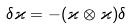<formula> <loc_0><loc_0><loc_500><loc_500>\delta \varkappa = - ( \varkappa \otimes \varkappa ) \delta</formula> 